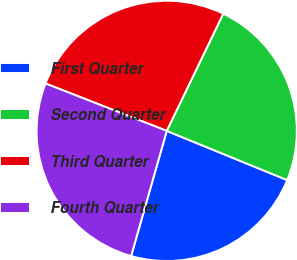Convert chart to OTSL. <chart><loc_0><loc_0><loc_500><loc_500><pie_chart><fcel>First Quarter<fcel>Second Quarter<fcel>Third Quarter<fcel>Fourth Quarter<nl><fcel>23.24%<fcel>24.02%<fcel>26.22%<fcel>26.52%<nl></chart> 